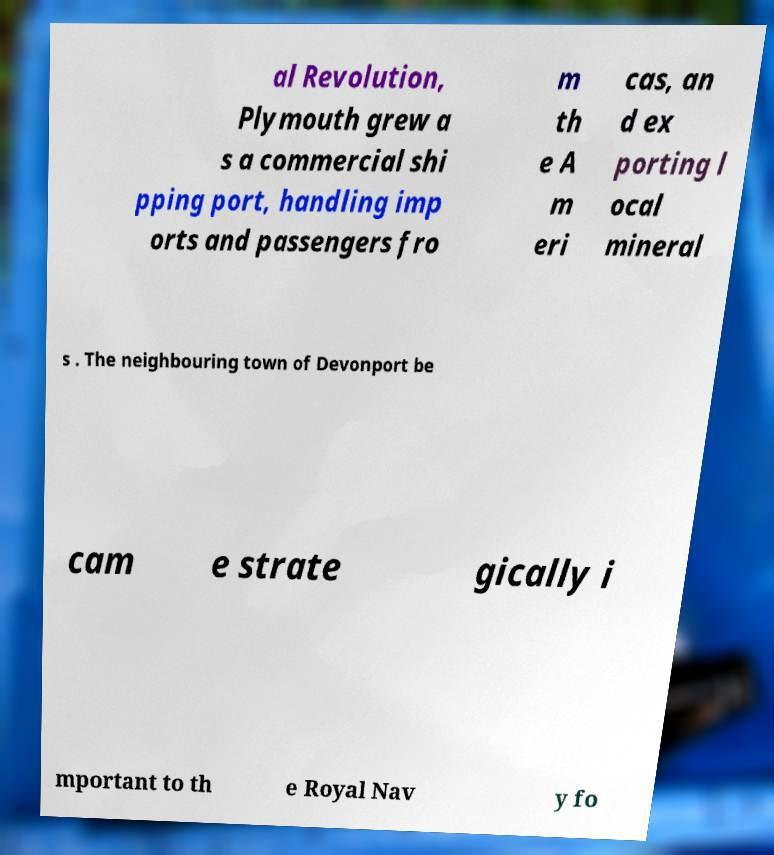What messages or text are displayed in this image? I need them in a readable, typed format. al Revolution, Plymouth grew a s a commercial shi pping port, handling imp orts and passengers fro m th e A m eri cas, an d ex porting l ocal mineral s . The neighbouring town of Devonport be cam e strate gically i mportant to th e Royal Nav y fo 